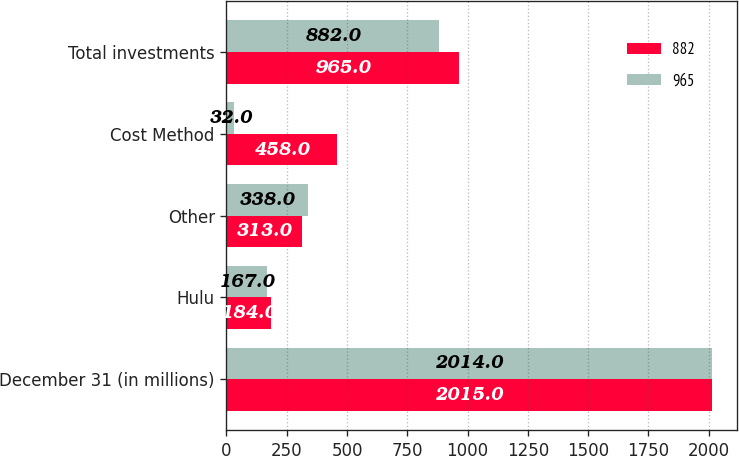Convert chart to OTSL. <chart><loc_0><loc_0><loc_500><loc_500><stacked_bar_chart><ecel><fcel>December 31 (in millions)<fcel>Hulu<fcel>Other<fcel>Cost Method<fcel>Total investments<nl><fcel>882<fcel>2015<fcel>184<fcel>313<fcel>458<fcel>965<nl><fcel>965<fcel>2014<fcel>167<fcel>338<fcel>32<fcel>882<nl></chart> 